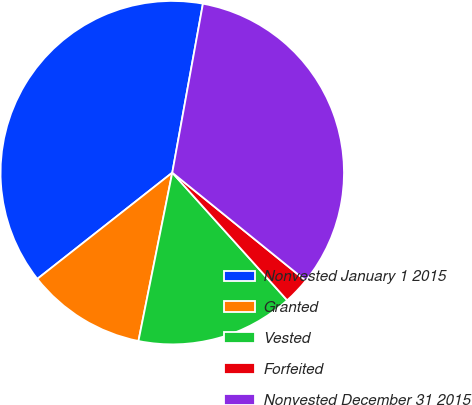<chart> <loc_0><loc_0><loc_500><loc_500><pie_chart><fcel>Nonvested January 1 2015<fcel>Granted<fcel>Vested<fcel>Forfeited<fcel>Nonvested December 31 2015<nl><fcel>38.47%<fcel>11.23%<fcel>14.82%<fcel>2.51%<fcel>32.97%<nl></chart> 